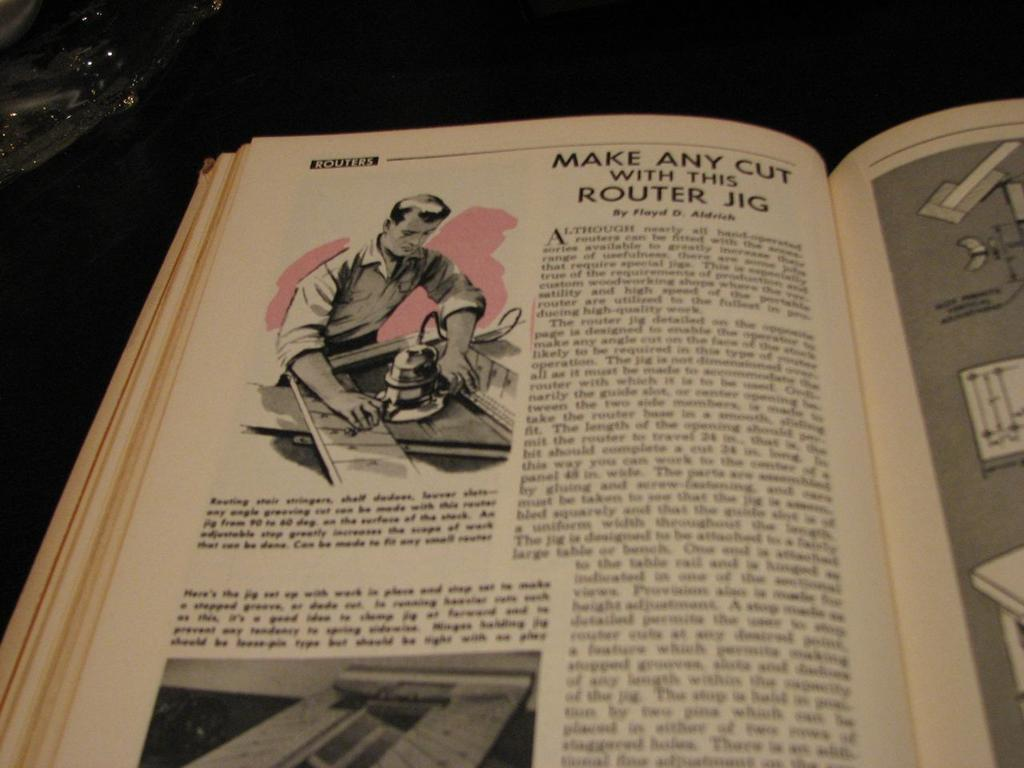Provide a one-sentence caption for the provided image. A vintage looking book that has a passage about how to make any cut with this router jig. 